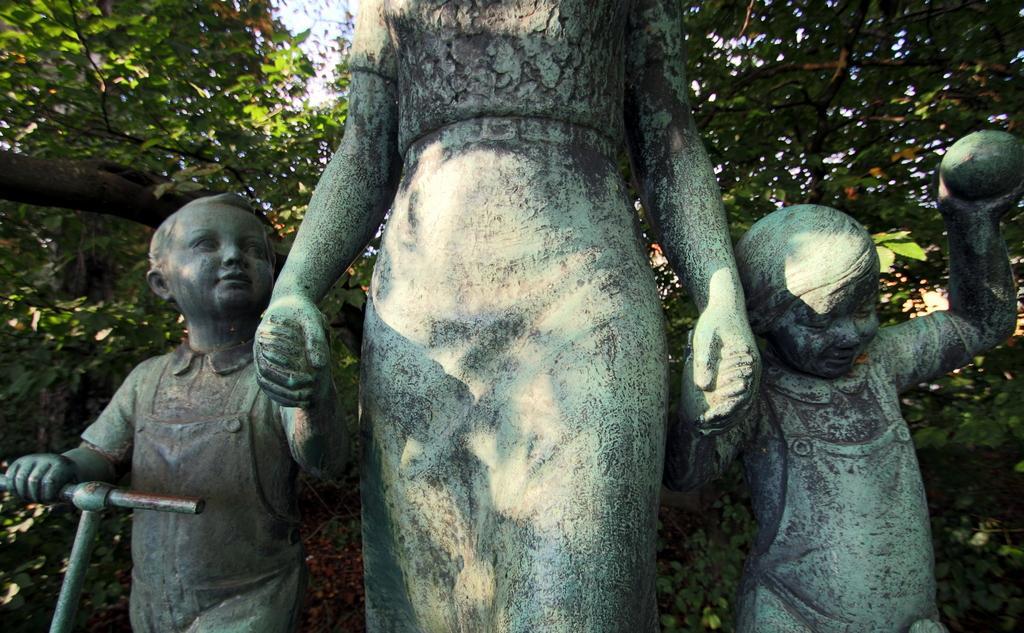How would you summarize this image in a sentence or two? In this picture there are statues of three people. At the back there are trees. At the top there is sky. 